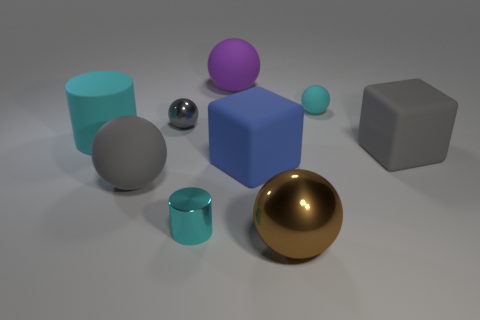Does the small cylinder have the same color as the large cylinder?
Your response must be concise. Yes. There is a small object that is on the right side of the brown metal ball; does it have the same color as the cylinder right of the big cyan object?
Make the answer very short. Yes. Are there an equal number of objects that are in front of the gray rubber cube and large matte things?
Your answer should be very brief. No. Do the tiny rubber thing and the cyan metal object have the same shape?
Offer a terse response. No. Are there any other things that are the same color as the big cylinder?
Your response must be concise. Yes. There is a big matte object that is to the right of the big purple ball and to the left of the gray matte cube; what is its shape?
Offer a terse response. Cube. Is the number of large spheres that are behind the small gray ball the same as the number of rubber cylinders that are in front of the big blue rubber object?
Make the answer very short. No. How many cubes are either red things or gray metallic objects?
Your answer should be compact. 0. How many big balls are the same material as the small gray object?
Give a very brief answer. 1. There is a tiny metal object that is the same color as the large cylinder; what is its shape?
Your answer should be very brief. Cylinder. 